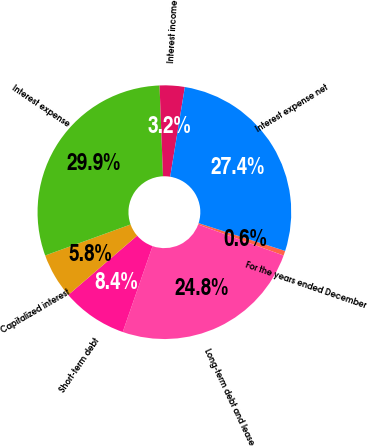Convert chart. <chart><loc_0><loc_0><loc_500><loc_500><pie_chart><fcel>For the years ended December<fcel>Long-term debt and lease<fcel>Short-term debt<fcel>Capitalized interest<fcel>Interest expense<fcel>Interest income<fcel>Interest expense net<nl><fcel>0.61%<fcel>24.78%<fcel>8.36%<fcel>5.77%<fcel>29.94%<fcel>3.19%<fcel>27.36%<nl></chart> 